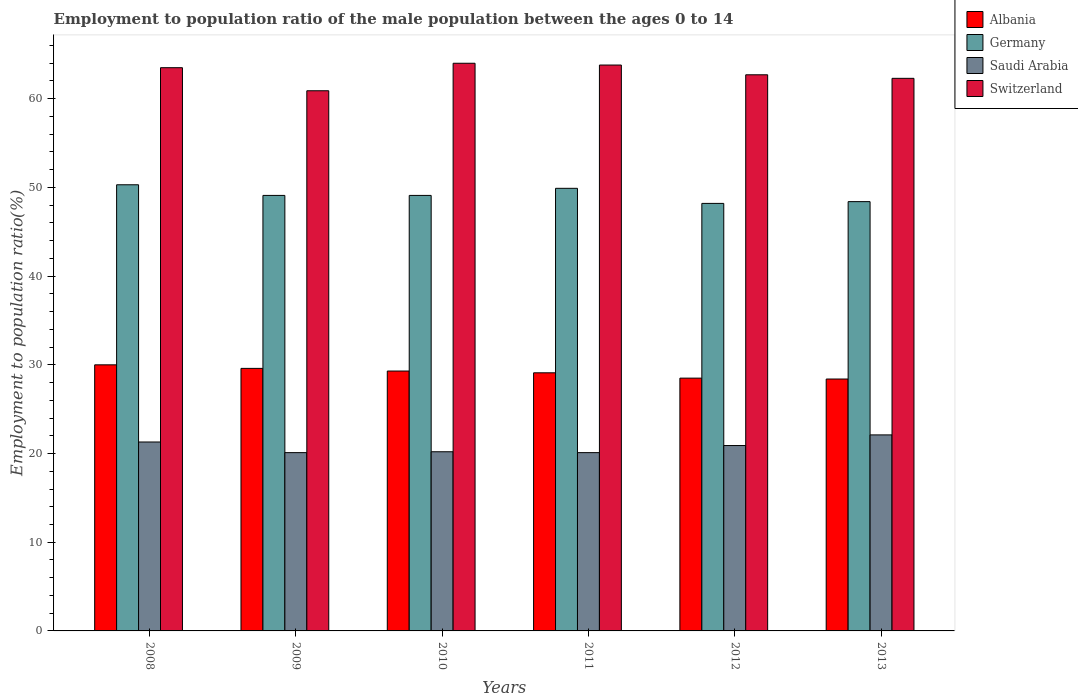How many different coloured bars are there?
Offer a very short reply. 4. How many bars are there on the 3rd tick from the left?
Give a very brief answer. 4. How many bars are there on the 6th tick from the right?
Your response must be concise. 4. What is the employment to population ratio in Switzerland in 2011?
Keep it short and to the point. 63.8. Across all years, what is the maximum employment to population ratio in Saudi Arabia?
Offer a very short reply. 22.1. Across all years, what is the minimum employment to population ratio in Switzerland?
Provide a succinct answer. 60.9. What is the total employment to population ratio in Germany in the graph?
Your answer should be compact. 295. What is the difference between the employment to population ratio in Switzerland in 2008 and that in 2011?
Offer a very short reply. -0.3. What is the difference between the employment to population ratio in Switzerland in 2011 and the employment to population ratio in Albania in 2012?
Make the answer very short. 35.3. What is the average employment to population ratio in Albania per year?
Your answer should be compact. 29.15. In the year 2012, what is the difference between the employment to population ratio in Switzerland and employment to population ratio in Saudi Arabia?
Your response must be concise. 41.8. In how many years, is the employment to population ratio in Albania greater than 58 %?
Make the answer very short. 0. What is the ratio of the employment to population ratio in Saudi Arabia in 2011 to that in 2012?
Provide a short and direct response. 0.96. What is the difference between the highest and the second highest employment to population ratio in Switzerland?
Ensure brevity in your answer.  0.2. What is the difference between the highest and the lowest employment to population ratio in Germany?
Make the answer very short. 2.1. Is the sum of the employment to population ratio in Albania in 2011 and 2013 greater than the maximum employment to population ratio in Saudi Arabia across all years?
Your answer should be compact. Yes. What does the 2nd bar from the left in 2010 represents?
Offer a very short reply. Germany. What does the 2nd bar from the right in 2009 represents?
Your answer should be compact. Saudi Arabia. How many years are there in the graph?
Make the answer very short. 6. What is the difference between two consecutive major ticks on the Y-axis?
Make the answer very short. 10. Does the graph contain any zero values?
Keep it short and to the point. No. How many legend labels are there?
Provide a short and direct response. 4. What is the title of the graph?
Offer a terse response. Employment to population ratio of the male population between the ages 0 to 14. Does "Qatar" appear as one of the legend labels in the graph?
Offer a very short reply. No. What is the Employment to population ratio(%) of Germany in 2008?
Your answer should be compact. 50.3. What is the Employment to population ratio(%) in Saudi Arabia in 2008?
Your response must be concise. 21.3. What is the Employment to population ratio(%) in Switzerland in 2008?
Provide a succinct answer. 63.5. What is the Employment to population ratio(%) in Albania in 2009?
Keep it short and to the point. 29.6. What is the Employment to population ratio(%) of Germany in 2009?
Your response must be concise. 49.1. What is the Employment to population ratio(%) of Saudi Arabia in 2009?
Offer a very short reply. 20.1. What is the Employment to population ratio(%) of Switzerland in 2009?
Give a very brief answer. 60.9. What is the Employment to population ratio(%) in Albania in 2010?
Your answer should be very brief. 29.3. What is the Employment to population ratio(%) in Germany in 2010?
Give a very brief answer. 49.1. What is the Employment to population ratio(%) in Saudi Arabia in 2010?
Offer a very short reply. 20.2. What is the Employment to population ratio(%) in Switzerland in 2010?
Offer a terse response. 64. What is the Employment to population ratio(%) in Albania in 2011?
Provide a short and direct response. 29.1. What is the Employment to population ratio(%) in Germany in 2011?
Make the answer very short. 49.9. What is the Employment to population ratio(%) of Saudi Arabia in 2011?
Make the answer very short. 20.1. What is the Employment to population ratio(%) of Switzerland in 2011?
Provide a succinct answer. 63.8. What is the Employment to population ratio(%) of Germany in 2012?
Your response must be concise. 48.2. What is the Employment to population ratio(%) of Saudi Arabia in 2012?
Offer a terse response. 20.9. What is the Employment to population ratio(%) in Switzerland in 2012?
Keep it short and to the point. 62.7. What is the Employment to population ratio(%) in Albania in 2013?
Keep it short and to the point. 28.4. What is the Employment to population ratio(%) of Germany in 2013?
Your answer should be very brief. 48.4. What is the Employment to population ratio(%) in Saudi Arabia in 2013?
Offer a very short reply. 22.1. What is the Employment to population ratio(%) of Switzerland in 2013?
Your response must be concise. 62.3. Across all years, what is the maximum Employment to population ratio(%) in Germany?
Provide a short and direct response. 50.3. Across all years, what is the maximum Employment to population ratio(%) of Saudi Arabia?
Provide a succinct answer. 22.1. Across all years, what is the minimum Employment to population ratio(%) in Albania?
Provide a succinct answer. 28.4. Across all years, what is the minimum Employment to population ratio(%) of Germany?
Make the answer very short. 48.2. Across all years, what is the minimum Employment to population ratio(%) of Saudi Arabia?
Give a very brief answer. 20.1. Across all years, what is the minimum Employment to population ratio(%) of Switzerland?
Provide a short and direct response. 60.9. What is the total Employment to population ratio(%) in Albania in the graph?
Provide a short and direct response. 174.9. What is the total Employment to population ratio(%) of Germany in the graph?
Make the answer very short. 295. What is the total Employment to population ratio(%) of Saudi Arabia in the graph?
Give a very brief answer. 124.7. What is the total Employment to population ratio(%) of Switzerland in the graph?
Ensure brevity in your answer.  377.2. What is the difference between the Employment to population ratio(%) in Germany in 2008 and that in 2009?
Make the answer very short. 1.2. What is the difference between the Employment to population ratio(%) in Saudi Arabia in 2008 and that in 2009?
Give a very brief answer. 1.2. What is the difference between the Employment to population ratio(%) of Switzerland in 2008 and that in 2009?
Offer a very short reply. 2.6. What is the difference between the Employment to population ratio(%) in Switzerland in 2008 and that in 2010?
Your answer should be very brief. -0.5. What is the difference between the Employment to population ratio(%) of Albania in 2008 and that in 2011?
Make the answer very short. 0.9. What is the difference between the Employment to population ratio(%) of Switzerland in 2008 and that in 2011?
Make the answer very short. -0.3. What is the difference between the Employment to population ratio(%) in Germany in 2008 and that in 2012?
Make the answer very short. 2.1. What is the difference between the Employment to population ratio(%) in Saudi Arabia in 2008 and that in 2012?
Your answer should be compact. 0.4. What is the difference between the Employment to population ratio(%) of Germany in 2008 and that in 2013?
Offer a terse response. 1.9. What is the difference between the Employment to population ratio(%) in Switzerland in 2009 and that in 2010?
Provide a succinct answer. -3.1. What is the difference between the Employment to population ratio(%) in Saudi Arabia in 2009 and that in 2011?
Give a very brief answer. 0. What is the difference between the Employment to population ratio(%) in Switzerland in 2009 and that in 2011?
Your answer should be very brief. -2.9. What is the difference between the Employment to population ratio(%) of Germany in 2009 and that in 2012?
Ensure brevity in your answer.  0.9. What is the difference between the Employment to population ratio(%) of Saudi Arabia in 2009 and that in 2012?
Offer a very short reply. -0.8. What is the difference between the Employment to population ratio(%) of Albania in 2009 and that in 2013?
Make the answer very short. 1.2. What is the difference between the Employment to population ratio(%) in Albania in 2010 and that in 2011?
Offer a very short reply. 0.2. What is the difference between the Employment to population ratio(%) of Germany in 2010 and that in 2011?
Your response must be concise. -0.8. What is the difference between the Employment to population ratio(%) of Albania in 2010 and that in 2012?
Your answer should be compact. 0.8. What is the difference between the Employment to population ratio(%) of Saudi Arabia in 2010 and that in 2012?
Provide a succinct answer. -0.7. What is the difference between the Employment to population ratio(%) of Switzerland in 2010 and that in 2012?
Your answer should be very brief. 1.3. What is the difference between the Employment to population ratio(%) in Saudi Arabia in 2010 and that in 2013?
Provide a succinct answer. -1.9. What is the difference between the Employment to population ratio(%) of Albania in 2011 and that in 2012?
Offer a terse response. 0.6. What is the difference between the Employment to population ratio(%) in Saudi Arabia in 2011 and that in 2012?
Provide a short and direct response. -0.8. What is the difference between the Employment to population ratio(%) in Switzerland in 2011 and that in 2012?
Keep it short and to the point. 1.1. What is the difference between the Employment to population ratio(%) of Germany in 2011 and that in 2013?
Make the answer very short. 1.5. What is the difference between the Employment to population ratio(%) of Albania in 2012 and that in 2013?
Provide a succinct answer. 0.1. What is the difference between the Employment to population ratio(%) in Saudi Arabia in 2012 and that in 2013?
Ensure brevity in your answer.  -1.2. What is the difference between the Employment to population ratio(%) of Albania in 2008 and the Employment to population ratio(%) of Germany in 2009?
Offer a terse response. -19.1. What is the difference between the Employment to population ratio(%) of Albania in 2008 and the Employment to population ratio(%) of Saudi Arabia in 2009?
Give a very brief answer. 9.9. What is the difference between the Employment to population ratio(%) in Albania in 2008 and the Employment to population ratio(%) in Switzerland in 2009?
Offer a terse response. -30.9. What is the difference between the Employment to population ratio(%) in Germany in 2008 and the Employment to population ratio(%) in Saudi Arabia in 2009?
Your answer should be compact. 30.2. What is the difference between the Employment to population ratio(%) in Germany in 2008 and the Employment to population ratio(%) in Switzerland in 2009?
Your response must be concise. -10.6. What is the difference between the Employment to population ratio(%) of Saudi Arabia in 2008 and the Employment to population ratio(%) of Switzerland in 2009?
Make the answer very short. -39.6. What is the difference between the Employment to population ratio(%) of Albania in 2008 and the Employment to population ratio(%) of Germany in 2010?
Give a very brief answer. -19.1. What is the difference between the Employment to population ratio(%) in Albania in 2008 and the Employment to population ratio(%) in Saudi Arabia in 2010?
Make the answer very short. 9.8. What is the difference between the Employment to population ratio(%) in Albania in 2008 and the Employment to population ratio(%) in Switzerland in 2010?
Your answer should be very brief. -34. What is the difference between the Employment to population ratio(%) in Germany in 2008 and the Employment to population ratio(%) in Saudi Arabia in 2010?
Your response must be concise. 30.1. What is the difference between the Employment to population ratio(%) in Germany in 2008 and the Employment to population ratio(%) in Switzerland in 2010?
Your response must be concise. -13.7. What is the difference between the Employment to population ratio(%) of Saudi Arabia in 2008 and the Employment to population ratio(%) of Switzerland in 2010?
Offer a very short reply. -42.7. What is the difference between the Employment to population ratio(%) in Albania in 2008 and the Employment to population ratio(%) in Germany in 2011?
Provide a short and direct response. -19.9. What is the difference between the Employment to population ratio(%) in Albania in 2008 and the Employment to population ratio(%) in Saudi Arabia in 2011?
Your answer should be very brief. 9.9. What is the difference between the Employment to population ratio(%) of Albania in 2008 and the Employment to population ratio(%) of Switzerland in 2011?
Keep it short and to the point. -33.8. What is the difference between the Employment to population ratio(%) in Germany in 2008 and the Employment to population ratio(%) in Saudi Arabia in 2011?
Make the answer very short. 30.2. What is the difference between the Employment to population ratio(%) of Saudi Arabia in 2008 and the Employment to population ratio(%) of Switzerland in 2011?
Offer a terse response. -42.5. What is the difference between the Employment to population ratio(%) in Albania in 2008 and the Employment to population ratio(%) in Germany in 2012?
Provide a short and direct response. -18.2. What is the difference between the Employment to population ratio(%) in Albania in 2008 and the Employment to population ratio(%) in Switzerland in 2012?
Ensure brevity in your answer.  -32.7. What is the difference between the Employment to population ratio(%) in Germany in 2008 and the Employment to population ratio(%) in Saudi Arabia in 2012?
Your response must be concise. 29.4. What is the difference between the Employment to population ratio(%) in Germany in 2008 and the Employment to population ratio(%) in Switzerland in 2012?
Make the answer very short. -12.4. What is the difference between the Employment to population ratio(%) of Saudi Arabia in 2008 and the Employment to population ratio(%) of Switzerland in 2012?
Your answer should be compact. -41.4. What is the difference between the Employment to population ratio(%) in Albania in 2008 and the Employment to population ratio(%) in Germany in 2013?
Provide a short and direct response. -18.4. What is the difference between the Employment to population ratio(%) of Albania in 2008 and the Employment to population ratio(%) of Switzerland in 2013?
Offer a very short reply. -32.3. What is the difference between the Employment to population ratio(%) of Germany in 2008 and the Employment to population ratio(%) of Saudi Arabia in 2013?
Ensure brevity in your answer.  28.2. What is the difference between the Employment to population ratio(%) in Saudi Arabia in 2008 and the Employment to population ratio(%) in Switzerland in 2013?
Make the answer very short. -41. What is the difference between the Employment to population ratio(%) of Albania in 2009 and the Employment to population ratio(%) of Germany in 2010?
Give a very brief answer. -19.5. What is the difference between the Employment to population ratio(%) of Albania in 2009 and the Employment to population ratio(%) of Saudi Arabia in 2010?
Offer a very short reply. 9.4. What is the difference between the Employment to population ratio(%) in Albania in 2009 and the Employment to population ratio(%) in Switzerland in 2010?
Ensure brevity in your answer.  -34.4. What is the difference between the Employment to population ratio(%) of Germany in 2009 and the Employment to population ratio(%) of Saudi Arabia in 2010?
Offer a terse response. 28.9. What is the difference between the Employment to population ratio(%) in Germany in 2009 and the Employment to population ratio(%) in Switzerland in 2010?
Make the answer very short. -14.9. What is the difference between the Employment to population ratio(%) of Saudi Arabia in 2009 and the Employment to population ratio(%) of Switzerland in 2010?
Your answer should be very brief. -43.9. What is the difference between the Employment to population ratio(%) of Albania in 2009 and the Employment to population ratio(%) of Germany in 2011?
Provide a succinct answer. -20.3. What is the difference between the Employment to population ratio(%) of Albania in 2009 and the Employment to population ratio(%) of Switzerland in 2011?
Ensure brevity in your answer.  -34.2. What is the difference between the Employment to population ratio(%) of Germany in 2009 and the Employment to population ratio(%) of Saudi Arabia in 2011?
Make the answer very short. 29. What is the difference between the Employment to population ratio(%) in Germany in 2009 and the Employment to population ratio(%) in Switzerland in 2011?
Keep it short and to the point. -14.7. What is the difference between the Employment to population ratio(%) of Saudi Arabia in 2009 and the Employment to population ratio(%) of Switzerland in 2011?
Make the answer very short. -43.7. What is the difference between the Employment to population ratio(%) of Albania in 2009 and the Employment to population ratio(%) of Germany in 2012?
Ensure brevity in your answer.  -18.6. What is the difference between the Employment to population ratio(%) of Albania in 2009 and the Employment to population ratio(%) of Saudi Arabia in 2012?
Ensure brevity in your answer.  8.7. What is the difference between the Employment to population ratio(%) of Albania in 2009 and the Employment to population ratio(%) of Switzerland in 2012?
Offer a very short reply. -33.1. What is the difference between the Employment to population ratio(%) in Germany in 2009 and the Employment to population ratio(%) in Saudi Arabia in 2012?
Keep it short and to the point. 28.2. What is the difference between the Employment to population ratio(%) of Germany in 2009 and the Employment to population ratio(%) of Switzerland in 2012?
Offer a terse response. -13.6. What is the difference between the Employment to population ratio(%) of Saudi Arabia in 2009 and the Employment to population ratio(%) of Switzerland in 2012?
Give a very brief answer. -42.6. What is the difference between the Employment to population ratio(%) of Albania in 2009 and the Employment to population ratio(%) of Germany in 2013?
Your response must be concise. -18.8. What is the difference between the Employment to population ratio(%) of Albania in 2009 and the Employment to population ratio(%) of Switzerland in 2013?
Provide a succinct answer. -32.7. What is the difference between the Employment to population ratio(%) in Germany in 2009 and the Employment to population ratio(%) in Saudi Arabia in 2013?
Offer a terse response. 27. What is the difference between the Employment to population ratio(%) in Germany in 2009 and the Employment to population ratio(%) in Switzerland in 2013?
Make the answer very short. -13.2. What is the difference between the Employment to population ratio(%) of Saudi Arabia in 2009 and the Employment to population ratio(%) of Switzerland in 2013?
Make the answer very short. -42.2. What is the difference between the Employment to population ratio(%) of Albania in 2010 and the Employment to population ratio(%) of Germany in 2011?
Offer a terse response. -20.6. What is the difference between the Employment to population ratio(%) of Albania in 2010 and the Employment to population ratio(%) of Switzerland in 2011?
Provide a short and direct response. -34.5. What is the difference between the Employment to population ratio(%) of Germany in 2010 and the Employment to population ratio(%) of Saudi Arabia in 2011?
Your answer should be very brief. 29. What is the difference between the Employment to population ratio(%) in Germany in 2010 and the Employment to population ratio(%) in Switzerland in 2011?
Your response must be concise. -14.7. What is the difference between the Employment to population ratio(%) in Saudi Arabia in 2010 and the Employment to population ratio(%) in Switzerland in 2011?
Offer a terse response. -43.6. What is the difference between the Employment to population ratio(%) in Albania in 2010 and the Employment to population ratio(%) in Germany in 2012?
Ensure brevity in your answer.  -18.9. What is the difference between the Employment to population ratio(%) in Albania in 2010 and the Employment to population ratio(%) in Saudi Arabia in 2012?
Make the answer very short. 8.4. What is the difference between the Employment to population ratio(%) in Albania in 2010 and the Employment to population ratio(%) in Switzerland in 2012?
Make the answer very short. -33.4. What is the difference between the Employment to population ratio(%) in Germany in 2010 and the Employment to population ratio(%) in Saudi Arabia in 2012?
Provide a succinct answer. 28.2. What is the difference between the Employment to population ratio(%) in Germany in 2010 and the Employment to population ratio(%) in Switzerland in 2012?
Your answer should be compact. -13.6. What is the difference between the Employment to population ratio(%) of Saudi Arabia in 2010 and the Employment to population ratio(%) of Switzerland in 2012?
Make the answer very short. -42.5. What is the difference between the Employment to population ratio(%) of Albania in 2010 and the Employment to population ratio(%) of Germany in 2013?
Keep it short and to the point. -19.1. What is the difference between the Employment to population ratio(%) of Albania in 2010 and the Employment to population ratio(%) of Saudi Arabia in 2013?
Give a very brief answer. 7.2. What is the difference between the Employment to population ratio(%) of Albania in 2010 and the Employment to population ratio(%) of Switzerland in 2013?
Provide a short and direct response. -33. What is the difference between the Employment to population ratio(%) of Germany in 2010 and the Employment to population ratio(%) of Switzerland in 2013?
Your response must be concise. -13.2. What is the difference between the Employment to population ratio(%) in Saudi Arabia in 2010 and the Employment to population ratio(%) in Switzerland in 2013?
Your response must be concise. -42.1. What is the difference between the Employment to population ratio(%) in Albania in 2011 and the Employment to population ratio(%) in Germany in 2012?
Ensure brevity in your answer.  -19.1. What is the difference between the Employment to population ratio(%) of Albania in 2011 and the Employment to population ratio(%) of Switzerland in 2012?
Give a very brief answer. -33.6. What is the difference between the Employment to population ratio(%) of Saudi Arabia in 2011 and the Employment to population ratio(%) of Switzerland in 2012?
Your answer should be compact. -42.6. What is the difference between the Employment to population ratio(%) of Albania in 2011 and the Employment to population ratio(%) of Germany in 2013?
Your answer should be compact. -19.3. What is the difference between the Employment to population ratio(%) of Albania in 2011 and the Employment to population ratio(%) of Saudi Arabia in 2013?
Your answer should be very brief. 7. What is the difference between the Employment to population ratio(%) in Albania in 2011 and the Employment to population ratio(%) in Switzerland in 2013?
Keep it short and to the point. -33.2. What is the difference between the Employment to population ratio(%) of Germany in 2011 and the Employment to population ratio(%) of Saudi Arabia in 2013?
Offer a terse response. 27.8. What is the difference between the Employment to population ratio(%) of Saudi Arabia in 2011 and the Employment to population ratio(%) of Switzerland in 2013?
Your response must be concise. -42.2. What is the difference between the Employment to population ratio(%) of Albania in 2012 and the Employment to population ratio(%) of Germany in 2013?
Provide a short and direct response. -19.9. What is the difference between the Employment to population ratio(%) in Albania in 2012 and the Employment to population ratio(%) in Saudi Arabia in 2013?
Make the answer very short. 6.4. What is the difference between the Employment to population ratio(%) of Albania in 2012 and the Employment to population ratio(%) of Switzerland in 2013?
Provide a succinct answer. -33.8. What is the difference between the Employment to population ratio(%) in Germany in 2012 and the Employment to population ratio(%) in Saudi Arabia in 2013?
Give a very brief answer. 26.1. What is the difference between the Employment to population ratio(%) in Germany in 2012 and the Employment to population ratio(%) in Switzerland in 2013?
Ensure brevity in your answer.  -14.1. What is the difference between the Employment to population ratio(%) in Saudi Arabia in 2012 and the Employment to population ratio(%) in Switzerland in 2013?
Your answer should be compact. -41.4. What is the average Employment to population ratio(%) of Albania per year?
Keep it short and to the point. 29.15. What is the average Employment to population ratio(%) of Germany per year?
Offer a very short reply. 49.17. What is the average Employment to population ratio(%) in Saudi Arabia per year?
Provide a succinct answer. 20.78. What is the average Employment to population ratio(%) in Switzerland per year?
Provide a short and direct response. 62.87. In the year 2008, what is the difference between the Employment to population ratio(%) of Albania and Employment to population ratio(%) of Germany?
Offer a very short reply. -20.3. In the year 2008, what is the difference between the Employment to population ratio(%) in Albania and Employment to population ratio(%) in Saudi Arabia?
Keep it short and to the point. 8.7. In the year 2008, what is the difference between the Employment to population ratio(%) of Albania and Employment to population ratio(%) of Switzerland?
Your answer should be very brief. -33.5. In the year 2008, what is the difference between the Employment to population ratio(%) in Germany and Employment to population ratio(%) in Saudi Arabia?
Your response must be concise. 29. In the year 2008, what is the difference between the Employment to population ratio(%) of Germany and Employment to population ratio(%) of Switzerland?
Offer a terse response. -13.2. In the year 2008, what is the difference between the Employment to population ratio(%) of Saudi Arabia and Employment to population ratio(%) of Switzerland?
Make the answer very short. -42.2. In the year 2009, what is the difference between the Employment to population ratio(%) in Albania and Employment to population ratio(%) in Germany?
Make the answer very short. -19.5. In the year 2009, what is the difference between the Employment to population ratio(%) of Albania and Employment to population ratio(%) of Saudi Arabia?
Make the answer very short. 9.5. In the year 2009, what is the difference between the Employment to population ratio(%) of Albania and Employment to population ratio(%) of Switzerland?
Give a very brief answer. -31.3. In the year 2009, what is the difference between the Employment to population ratio(%) in Saudi Arabia and Employment to population ratio(%) in Switzerland?
Provide a succinct answer. -40.8. In the year 2010, what is the difference between the Employment to population ratio(%) in Albania and Employment to population ratio(%) in Germany?
Your response must be concise. -19.8. In the year 2010, what is the difference between the Employment to population ratio(%) of Albania and Employment to population ratio(%) of Switzerland?
Ensure brevity in your answer.  -34.7. In the year 2010, what is the difference between the Employment to population ratio(%) in Germany and Employment to population ratio(%) in Saudi Arabia?
Provide a short and direct response. 28.9. In the year 2010, what is the difference between the Employment to population ratio(%) in Germany and Employment to population ratio(%) in Switzerland?
Your answer should be compact. -14.9. In the year 2010, what is the difference between the Employment to population ratio(%) of Saudi Arabia and Employment to population ratio(%) of Switzerland?
Your answer should be compact. -43.8. In the year 2011, what is the difference between the Employment to population ratio(%) of Albania and Employment to population ratio(%) of Germany?
Provide a short and direct response. -20.8. In the year 2011, what is the difference between the Employment to population ratio(%) of Albania and Employment to population ratio(%) of Saudi Arabia?
Give a very brief answer. 9. In the year 2011, what is the difference between the Employment to population ratio(%) of Albania and Employment to population ratio(%) of Switzerland?
Offer a very short reply. -34.7. In the year 2011, what is the difference between the Employment to population ratio(%) of Germany and Employment to population ratio(%) of Saudi Arabia?
Offer a very short reply. 29.8. In the year 2011, what is the difference between the Employment to population ratio(%) of Saudi Arabia and Employment to population ratio(%) of Switzerland?
Keep it short and to the point. -43.7. In the year 2012, what is the difference between the Employment to population ratio(%) in Albania and Employment to population ratio(%) in Germany?
Make the answer very short. -19.7. In the year 2012, what is the difference between the Employment to population ratio(%) in Albania and Employment to population ratio(%) in Saudi Arabia?
Your answer should be compact. 7.6. In the year 2012, what is the difference between the Employment to population ratio(%) in Albania and Employment to population ratio(%) in Switzerland?
Your answer should be compact. -34.2. In the year 2012, what is the difference between the Employment to population ratio(%) in Germany and Employment to population ratio(%) in Saudi Arabia?
Your answer should be compact. 27.3. In the year 2012, what is the difference between the Employment to population ratio(%) in Saudi Arabia and Employment to population ratio(%) in Switzerland?
Ensure brevity in your answer.  -41.8. In the year 2013, what is the difference between the Employment to population ratio(%) in Albania and Employment to population ratio(%) in Germany?
Offer a very short reply. -20. In the year 2013, what is the difference between the Employment to population ratio(%) in Albania and Employment to population ratio(%) in Switzerland?
Provide a succinct answer. -33.9. In the year 2013, what is the difference between the Employment to population ratio(%) of Germany and Employment to population ratio(%) of Saudi Arabia?
Your response must be concise. 26.3. In the year 2013, what is the difference between the Employment to population ratio(%) in Saudi Arabia and Employment to population ratio(%) in Switzerland?
Provide a short and direct response. -40.2. What is the ratio of the Employment to population ratio(%) of Albania in 2008 to that in 2009?
Your response must be concise. 1.01. What is the ratio of the Employment to population ratio(%) of Germany in 2008 to that in 2009?
Ensure brevity in your answer.  1.02. What is the ratio of the Employment to population ratio(%) in Saudi Arabia in 2008 to that in 2009?
Provide a succinct answer. 1.06. What is the ratio of the Employment to population ratio(%) of Switzerland in 2008 to that in 2009?
Your response must be concise. 1.04. What is the ratio of the Employment to population ratio(%) of Albania in 2008 to that in 2010?
Offer a terse response. 1.02. What is the ratio of the Employment to population ratio(%) of Germany in 2008 to that in 2010?
Give a very brief answer. 1.02. What is the ratio of the Employment to population ratio(%) in Saudi Arabia in 2008 to that in 2010?
Give a very brief answer. 1.05. What is the ratio of the Employment to population ratio(%) in Switzerland in 2008 to that in 2010?
Provide a short and direct response. 0.99. What is the ratio of the Employment to population ratio(%) of Albania in 2008 to that in 2011?
Give a very brief answer. 1.03. What is the ratio of the Employment to population ratio(%) in Saudi Arabia in 2008 to that in 2011?
Your response must be concise. 1.06. What is the ratio of the Employment to population ratio(%) in Switzerland in 2008 to that in 2011?
Your answer should be compact. 1. What is the ratio of the Employment to population ratio(%) in Albania in 2008 to that in 2012?
Offer a terse response. 1.05. What is the ratio of the Employment to population ratio(%) of Germany in 2008 to that in 2012?
Keep it short and to the point. 1.04. What is the ratio of the Employment to population ratio(%) of Saudi Arabia in 2008 to that in 2012?
Make the answer very short. 1.02. What is the ratio of the Employment to population ratio(%) of Switzerland in 2008 to that in 2012?
Give a very brief answer. 1.01. What is the ratio of the Employment to population ratio(%) in Albania in 2008 to that in 2013?
Your answer should be very brief. 1.06. What is the ratio of the Employment to population ratio(%) in Germany in 2008 to that in 2013?
Make the answer very short. 1.04. What is the ratio of the Employment to population ratio(%) in Saudi Arabia in 2008 to that in 2013?
Your answer should be compact. 0.96. What is the ratio of the Employment to population ratio(%) of Switzerland in 2008 to that in 2013?
Your response must be concise. 1.02. What is the ratio of the Employment to population ratio(%) of Albania in 2009 to that in 2010?
Provide a succinct answer. 1.01. What is the ratio of the Employment to population ratio(%) in Switzerland in 2009 to that in 2010?
Offer a very short reply. 0.95. What is the ratio of the Employment to population ratio(%) of Albania in 2009 to that in 2011?
Ensure brevity in your answer.  1.02. What is the ratio of the Employment to population ratio(%) of Switzerland in 2009 to that in 2011?
Your answer should be compact. 0.95. What is the ratio of the Employment to population ratio(%) of Albania in 2009 to that in 2012?
Offer a terse response. 1.04. What is the ratio of the Employment to population ratio(%) in Germany in 2009 to that in 2012?
Offer a very short reply. 1.02. What is the ratio of the Employment to population ratio(%) in Saudi Arabia in 2009 to that in 2012?
Your response must be concise. 0.96. What is the ratio of the Employment to population ratio(%) in Switzerland in 2009 to that in 2012?
Provide a short and direct response. 0.97. What is the ratio of the Employment to population ratio(%) in Albania in 2009 to that in 2013?
Ensure brevity in your answer.  1.04. What is the ratio of the Employment to population ratio(%) of Germany in 2009 to that in 2013?
Provide a succinct answer. 1.01. What is the ratio of the Employment to population ratio(%) of Saudi Arabia in 2009 to that in 2013?
Ensure brevity in your answer.  0.91. What is the ratio of the Employment to population ratio(%) in Switzerland in 2009 to that in 2013?
Provide a short and direct response. 0.98. What is the ratio of the Employment to population ratio(%) in Saudi Arabia in 2010 to that in 2011?
Your answer should be compact. 1. What is the ratio of the Employment to population ratio(%) of Switzerland in 2010 to that in 2011?
Your answer should be compact. 1. What is the ratio of the Employment to population ratio(%) of Albania in 2010 to that in 2012?
Offer a terse response. 1.03. What is the ratio of the Employment to population ratio(%) of Germany in 2010 to that in 2012?
Provide a short and direct response. 1.02. What is the ratio of the Employment to population ratio(%) of Saudi Arabia in 2010 to that in 2012?
Keep it short and to the point. 0.97. What is the ratio of the Employment to population ratio(%) in Switzerland in 2010 to that in 2012?
Offer a very short reply. 1.02. What is the ratio of the Employment to population ratio(%) in Albania in 2010 to that in 2013?
Make the answer very short. 1.03. What is the ratio of the Employment to population ratio(%) in Germany in 2010 to that in 2013?
Ensure brevity in your answer.  1.01. What is the ratio of the Employment to population ratio(%) of Saudi Arabia in 2010 to that in 2013?
Provide a short and direct response. 0.91. What is the ratio of the Employment to population ratio(%) of Switzerland in 2010 to that in 2013?
Give a very brief answer. 1.03. What is the ratio of the Employment to population ratio(%) of Albania in 2011 to that in 2012?
Your answer should be compact. 1.02. What is the ratio of the Employment to population ratio(%) of Germany in 2011 to that in 2012?
Keep it short and to the point. 1.04. What is the ratio of the Employment to population ratio(%) of Saudi Arabia in 2011 to that in 2012?
Your answer should be compact. 0.96. What is the ratio of the Employment to population ratio(%) in Switzerland in 2011 to that in 2012?
Offer a very short reply. 1.02. What is the ratio of the Employment to population ratio(%) in Albania in 2011 to that in 2013?
Offer a terse response. 1.02. What is the ratio of the Employment to population ratio(%) of Germany in 2011 to that in 2013?
Your response must be concise. 1.03. What is the ratio of the Employment to population ratio(%) of Saudi Arabia in 2011 to that in 2013?
Your answer should be very brief. 0.91. What is the ratio of the Employment to population ratio(%) in Switzerland in 2011 to that in 2013?
Make the answer very short. 1.02. What is the ratio of the Employment to population ratio(%) in Germany in 2012 to that in 2013?
Make the answer very short. 1. What is the ratio of the Employment to population ratio(%) in Saudi Arabia in 2012 to that in 2013?
Your response must be concise. 0.95. What is the ratio of the Employment to population ratio(%) of Switzerland in 2012 to that in 2013?
Ensure brevity in your answer.  1.01. What is the difference between the highest and the second highest Employment to population ratio(%) in Albania?
Provide a short and direct response. 0.4. What is the difference between the highest and the second highest Employment to population ratio(%) in Germany?
Your response must be concise. 0.4. What is the difference between the highest and the second highest Employment to population ratio(%) in Switzerland?
Provide a short and direct response. 0.2. What is the difference between the highest and the lowest Employment to population ratio(%) of Albania?
Provide a succinct answer. 1.6. What is the difference between the highest and the lowest Employment to population ratio(%) of Germany?
Your answer should be compact. 2.1. What is the difference between the highest and the lowest Employment to population ratio(%) in Switzerland?
Give a very brief answer. 3.1. 